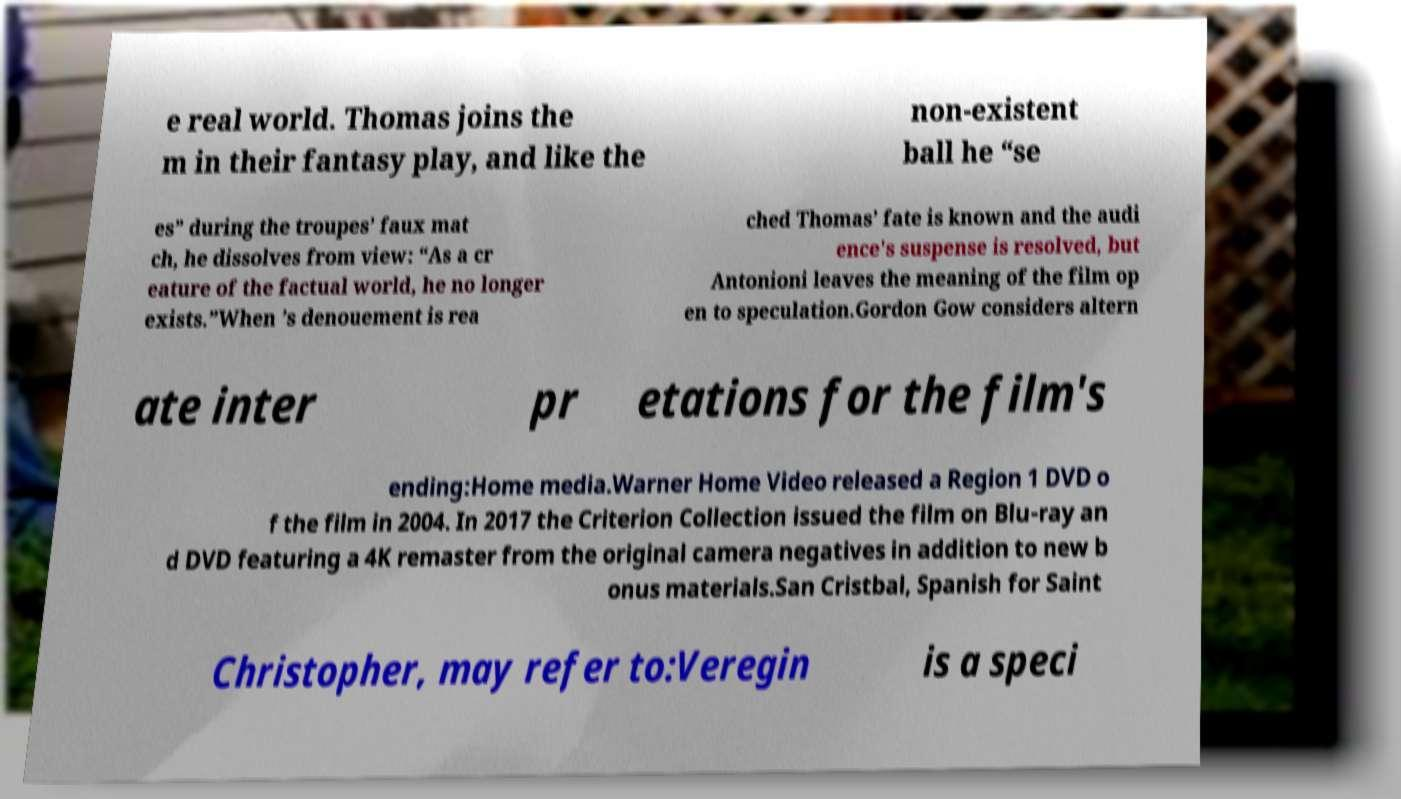Can you accurately transcribe the text from the provided image for me? e real world. Thomas joins the m in their fantasy play, and like the non-existent ball he “se es” during the troupes’ faux mat ch, he dissolves from view: “As a cr eature of the factual world, he no longer exists.”When ’s denouement is rea ched Thomas’ fate is known and the audi ence's suspense is resolved, but Antonioni leaves the meaning of the film op en to speculation.Gordon Gow considers altern ate inter pr etations for the film's ending:Home media.Warner Home Video released a Region 1 DVD o f the film in 2004. In 2017 the Criterion Collection issued the film on Blu-ray an d DVD featuring a 4K remaster from the original camera negatives in addition to new b onus materials.San Cristbal, Spanish for Saint Christopher, may refer to:Veregin is a speci 